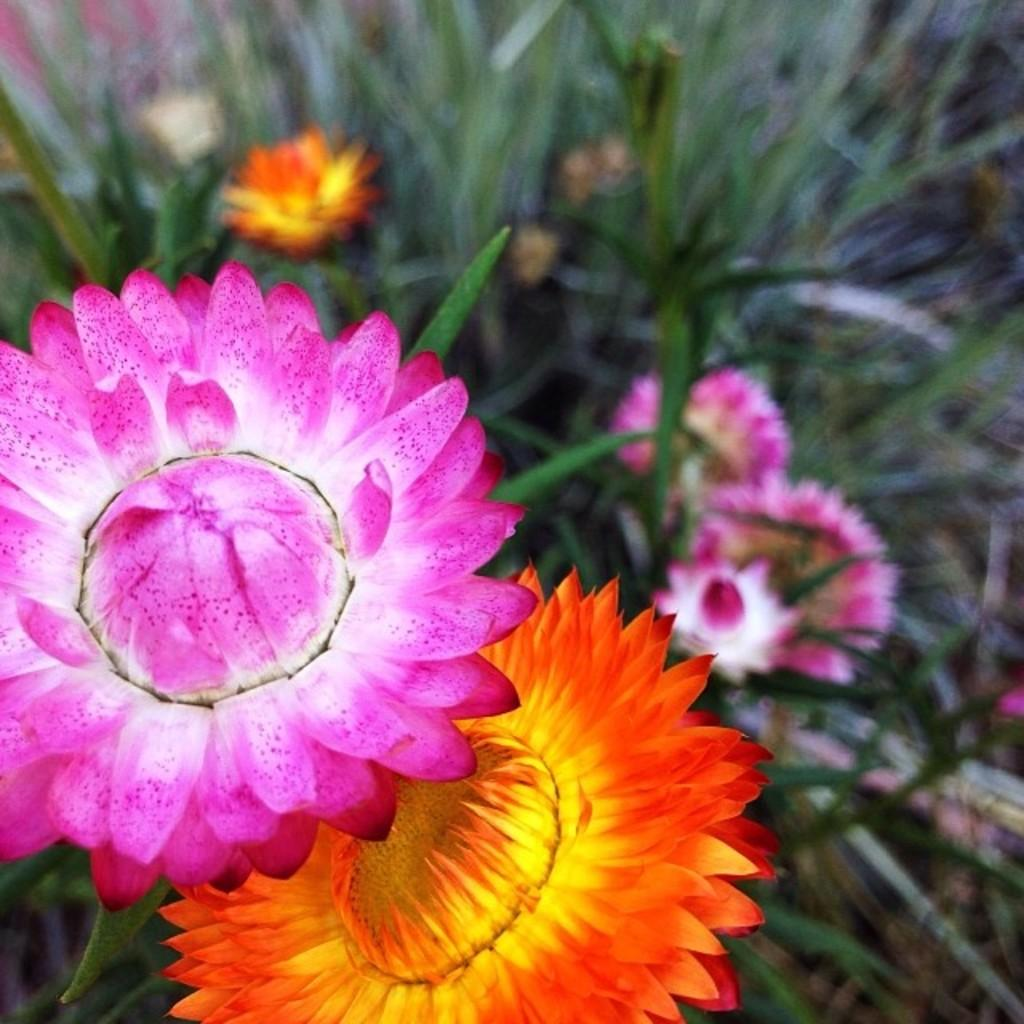What type of living organisms can be seen in the image? Plants can be seen in the image. What specific features can be observed on the plants? The plants have flowers, and the flowers are in pink and orange colors. What color are the leaves of the plants? The leaves are in green color. Can you see a bee flying around the flowers in the image? There is no bee present in the image; it only features plants with flowers and leaves. What type of paper is used to create the flowers in the image? The flowers in the image are not made of paper; they are real flowers on the plants. 